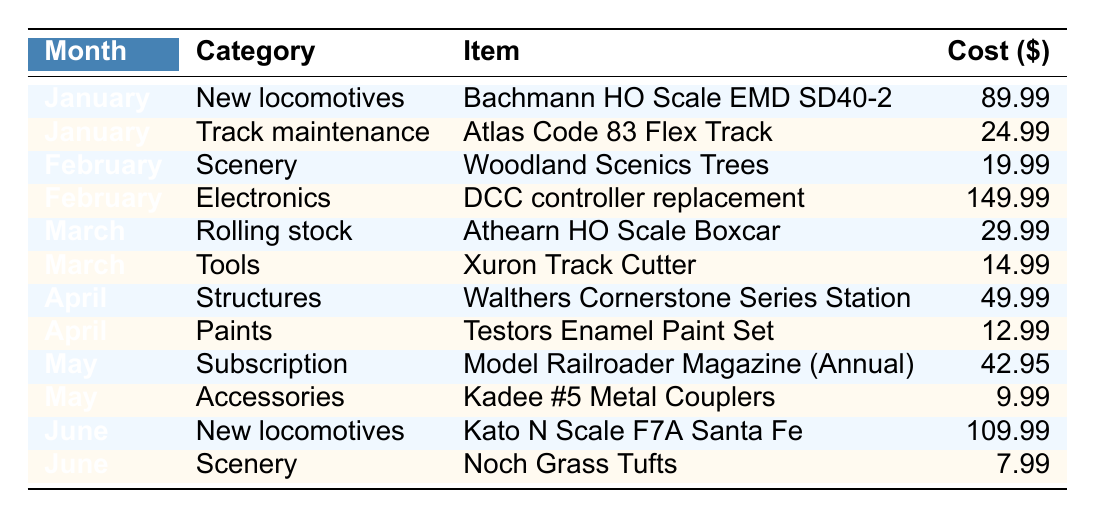What was the total monthly expense for January? In January, the expenses include $89.99 for a new locomotive and $24.99 for track maintenance. Adding these together: 89.99 + 24.99 = 114.98.
Answer: 114.98 How much was spent on scenery in February? The only scenery-related expense in February is $19.99 for Woodland Scenics Trees.
Answer: 19.99 Did any month have expenses for accessories? Yes, in May there was an expense for $9.99 for Kadee #5 Metal Couplers categorized as accessories.
Answer: Yes What is the average cost of all items purchased in March? The costs in March are $29.99 for an Athearn HO Scale Boxcar and $14.99 for a Xuron Track Cutter. The total cost is 29.99 + 14.99 = 44.98. There are 2 items, so the average is 44.98/2 = 22.49.
Answer: 22.49 Which month had the highest single expense and what was it? In February, there is an expense of $149.99 for the DCC controller replacement, which is the highest single expense compared to other months.
Answer: February, 149.99 What was the total spending on new locomotives across all months? In January, $89.99 was spent on a Bachmann locomotive, and in June, $109.99 was spent on a Kato locomotive. Adding these: 89.99 + 109.99 = 199.98.
Answer: 199.98 Which category had the least total expense during the period? Analyzing the expenses, Paints in April had only one expense of $12.99, which is the least compared to other categories.
Answer: Paints Is there any month that did not have any expenses for tools? Yes, the months of January, February, April, and May did not have any expenses for tools. Only March had a $14.99 expense for tools.
Answer: Yes What was the total expense across all months for subscription items? The only subscription item was in May, costing $42.95 for the Model Railroader Magazine. Therefore, the total expense for subscription items is $42.95.
Answer: 42.95 If you combine all expenses from June, what would the total be? In June, expenses include $109.99 for a new locomotive and $7.99 for scenery. Adding these gives 109.99 + 7.99 = 117.98.
Answer: 117.98 